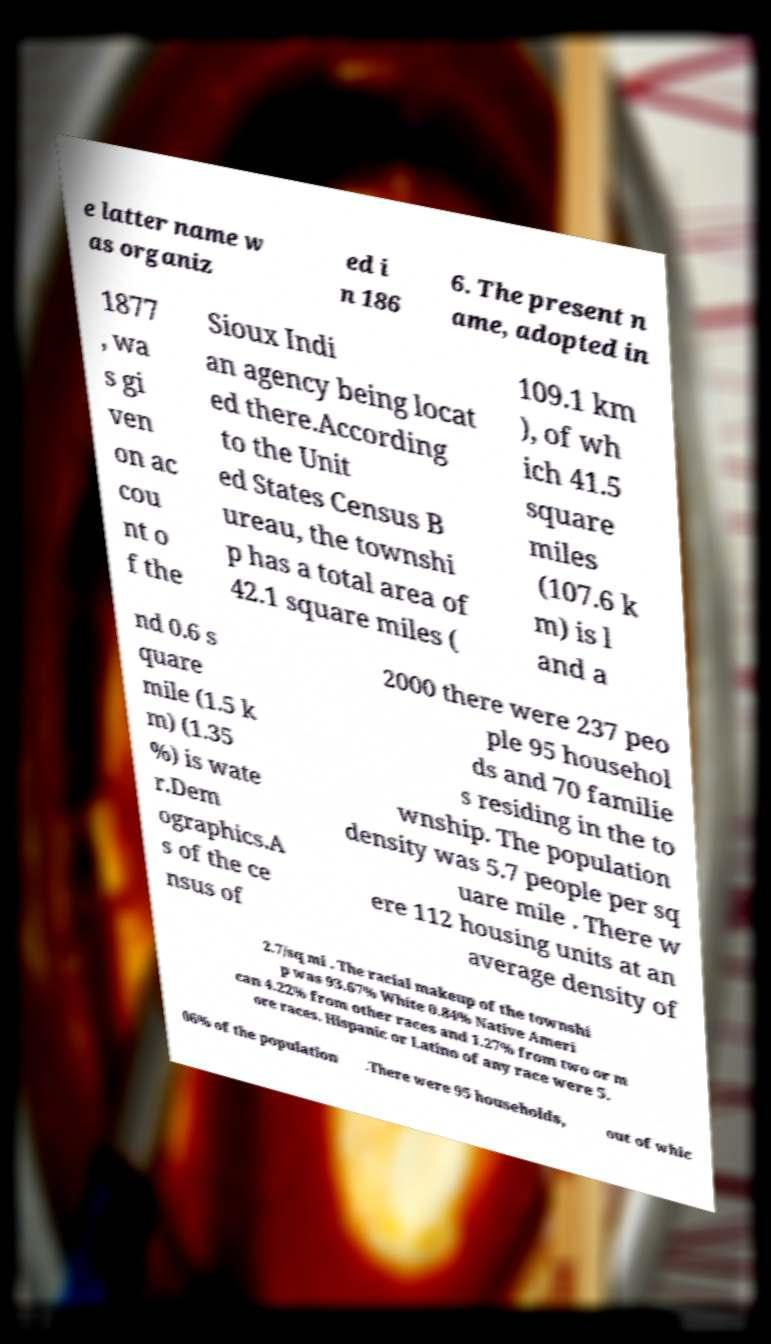Please read and relay the text visible in this image. What does it say? e latter name w as organiz ed i n 186 6. The present n ame, adopted in 1877 , wa s gi ven on ac cou nt o f the Sioux Indi an agency being locat ed there.According to the Unit ed States Census B ureau, the townshi p has a total area of 42.1 square miles ( 109.1 km ), of wh ich 41.5 square miles (107.6 k m) is l and a nd 0.6 s quare mile (1.5 k m) (1.35 %) is wate r.Dem ographics.A s of the ce nsus of 2000 there were 237 peo ple 95 househol ds and 70 familie s residing in the to wnship. The population density was 5.7 people per sq uare mile . There w ere 112 housing units at an average density of 2.7/sq mi . The racial makeup of the townshi p was 93.67% White 0.84% Native Ameri can 4.22% from other races and 1.27% from two or m ore races. Hispanic or Latino of any race were 5. 06% of the population .There were 95 households, out of whic 